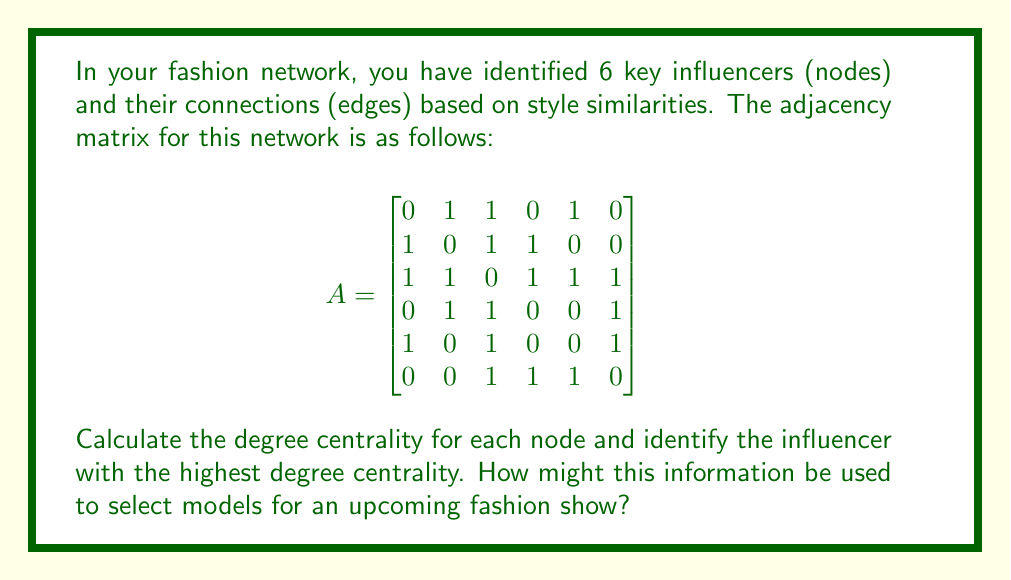Can you solve this math problem? To solve this problem, we'll follow these steps:

1) First, let's understand what degree centrality means in this context. Degree centrality is a measure of the number of direct connections a node has in a network. In our fashion network, it represents how many direct style connections an influencer has with others.

2) To calculate the degree centrality, we need to sum up the rows (or columns, since this is an undirected graph) of the adjacency matrix. The degree centrality for each node is:

   Node 1: $1 + 1 + 0 + 1 + 0 = 3$
   Node 2: $1 + 1 + 1 + 0 + 0 = 3$
   Node 3: $1 + 1 + 1 + 1 + 1 = 5$
   Node 4: $0 + 1 + 1 + 0 + 1 = 3$
   Node 5: $1 + 0 + 1 + 0 + 1 = 3$
   Node 6: $0 + 0 + 1 + 1 + 1 = 3$

3) The node with the highest degree centrality is Node 3, with a degree of 5.

4) In the context of a model agency and fashion show:
   - The degree centrality indicates how well-connected an influencer is in terms of style similarities.
   - Node 3, having the highest degree centrality, represents an influencer whose style has the most connections or similarities with others in the network.
   - This influencer could be seen as a trendsetter or someone who embodies a style that resonates with many others.

5) For selecting models for an upcoming fashion show:
   - Models who can embody the style of the most central influencer (Node 3) might be prioritized, as this style seems to have the widest appeal or connection in the network.
   - However, it's also important to consider the other nodes. While they have lower centrality, they might represent unique styles that add diversity to the show.
   - The connections between nodes could inform how to group or transition between different styles in the show's lineup.
Answer: The influencer with the highest degree centrality is Node 3, with a degree centrality of 5. This information can be used to select models who can embody the style of this central influencer for the upcoming fashion show, potentially showcasing looks that have the widest appeal or connection within the current fashion network. 